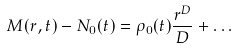<formula> <loc_0><loc_0><loc_500><loc_500>M ( r , t ) - N _ { 0 } ( t ) = \rho _ { 0 } ( t ) \frac { r ^ { D } } { D } + \dots</formula> 